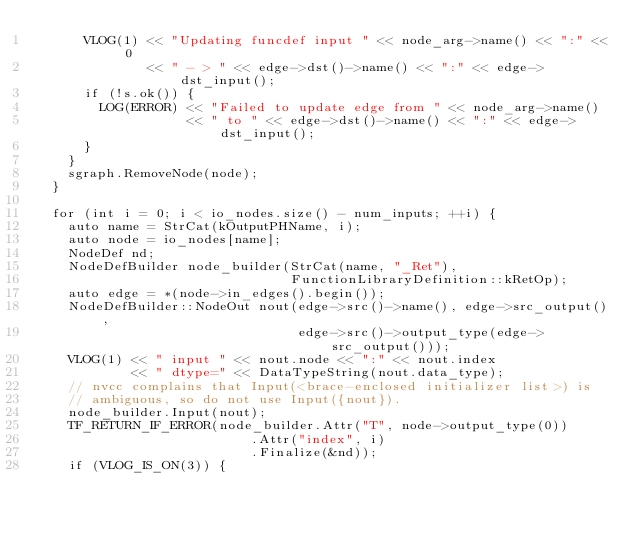Convert code to text. <code><loc_0><loc_0><loc_500><loc_500><_C++_>      VLOG(1) << "Updating funcdef input " << node_arg->name() << ":" << 0
              << " - > " << edge->dst()->name() << ":" << edge->dst_input();
      if (!s.ok()) {
        LOG(ERROR) << "Failed to update edge from " << node_arg->name()
                   << " to " << edge->dst()->name() << ":" << edge->dst_input();
      }
    }
    sgraph.RemoveNode(node);
  }

  for (int i = 0; i < io_nodes.size() - num_inputs; ++i) {
    auto name = StrCat(kOutputPHName, i);
    auto node = io_nodes[name];
    NodeDef nd;
    NodeDefBuilder node_builder(StrCat(name, "_Ret"),
                                FunctionLibraryDefinition::kRetOp);
    auto edge = *(node->in_edges().begin());
    NodeDefBuilder::NodeOut nout(edge->src()->name(), edge->src_output(),
                                 edge->src()->output_type(edge->src_output()));
    VLOG(1) << " input " << nout.node << ":" << nout.index
            << " dtype=" << DataTypeString(nout.data_type);
    // nvcc complains that Input(<brace-enclosed initializer list>) is
    // ambiguous, so do not use Input({nout}).
    node_builder.Input(nout);
    TF_RETURN_IF_ERROR(node_builder.Attr("T", node->output_type(0))
                           .Attr("index", i)
                           .Finalize(&nd));
    if (VLOG_IS_ON(3)) {</code> 